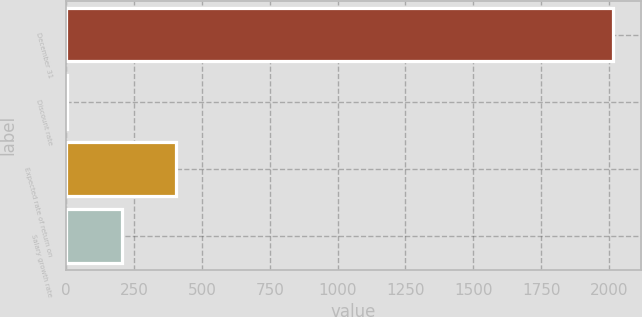<chart> <loc_0><loc_0><loc_500><loc_500><bar_chart><fcel>December 31<fcel>Discount rate<fcel>Expected rate of return on<fcel>Salary growth rate<nl><fcel>2016<fcel>2.8<fcel>405.44<fcel>204.12<nl></chart> 